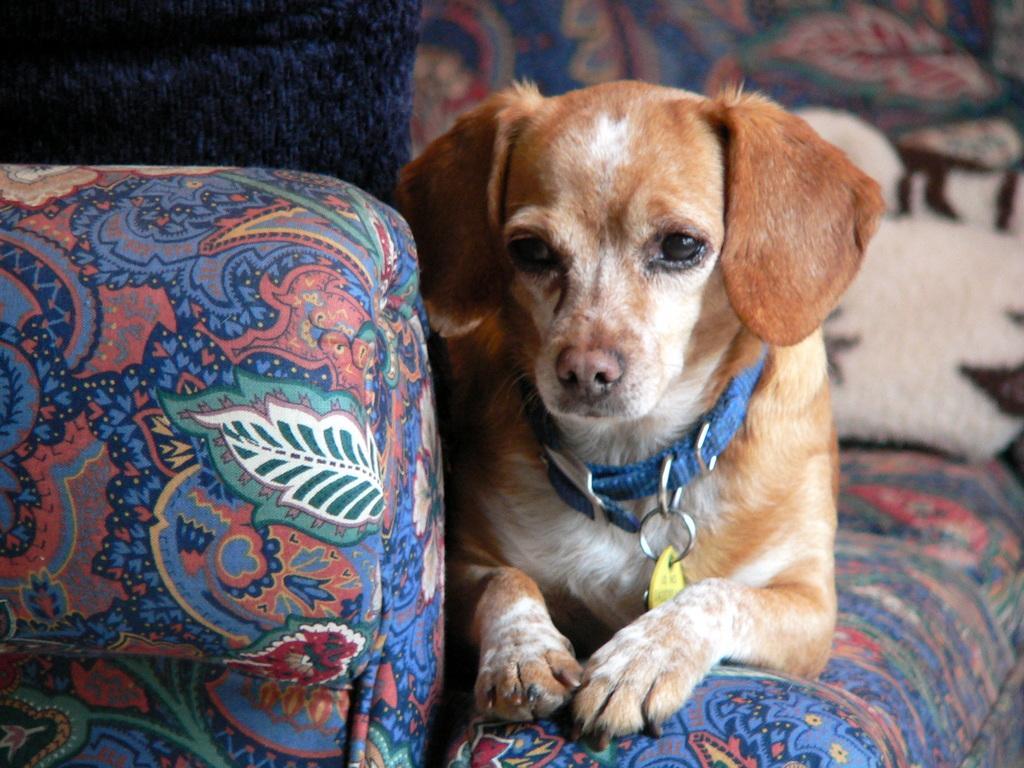Please provide a concise description of this image. In this picture we can observe a dog which is in white and brown color sitting in the sofa. We can observe a blue color belt around its neck. In the background there is a blue color sofa. 